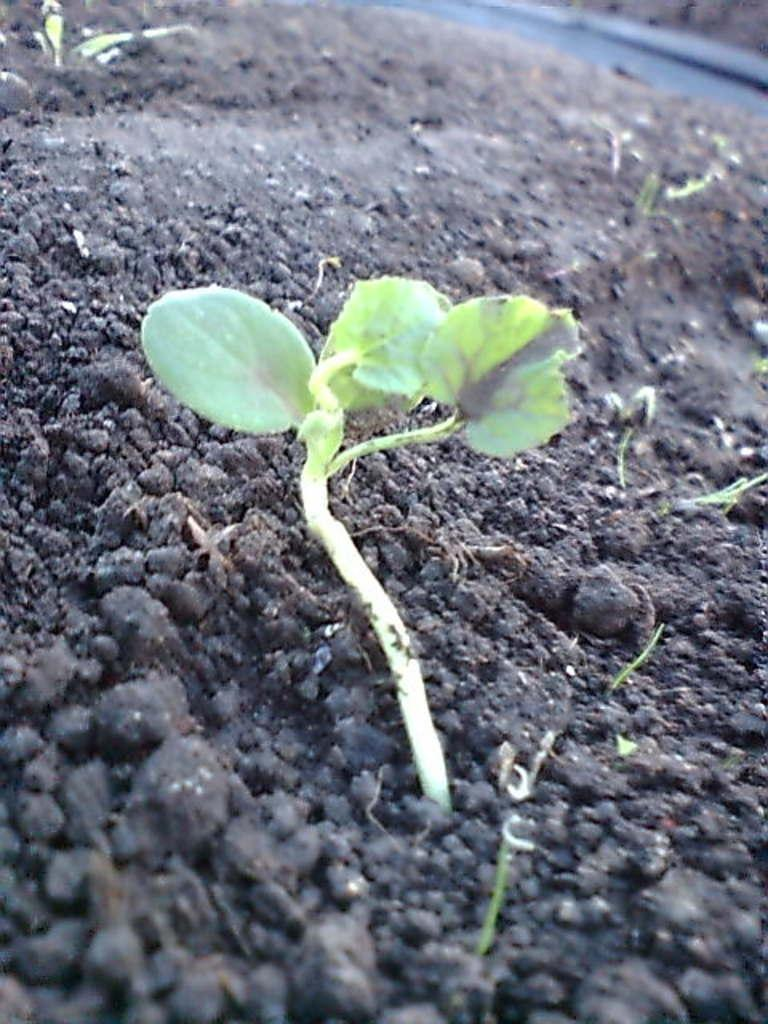What type of living organisms can be seen on the ground in the image? There are plants on the ground in the image. Can you describe the object visible in the background of the image? Unfortunately, the provided facts do not give any details about the object in the background. What type of cracker is being used as a sorting tool on the throne in the image? There is no cracker, sorting tool, or throne present in the image. 